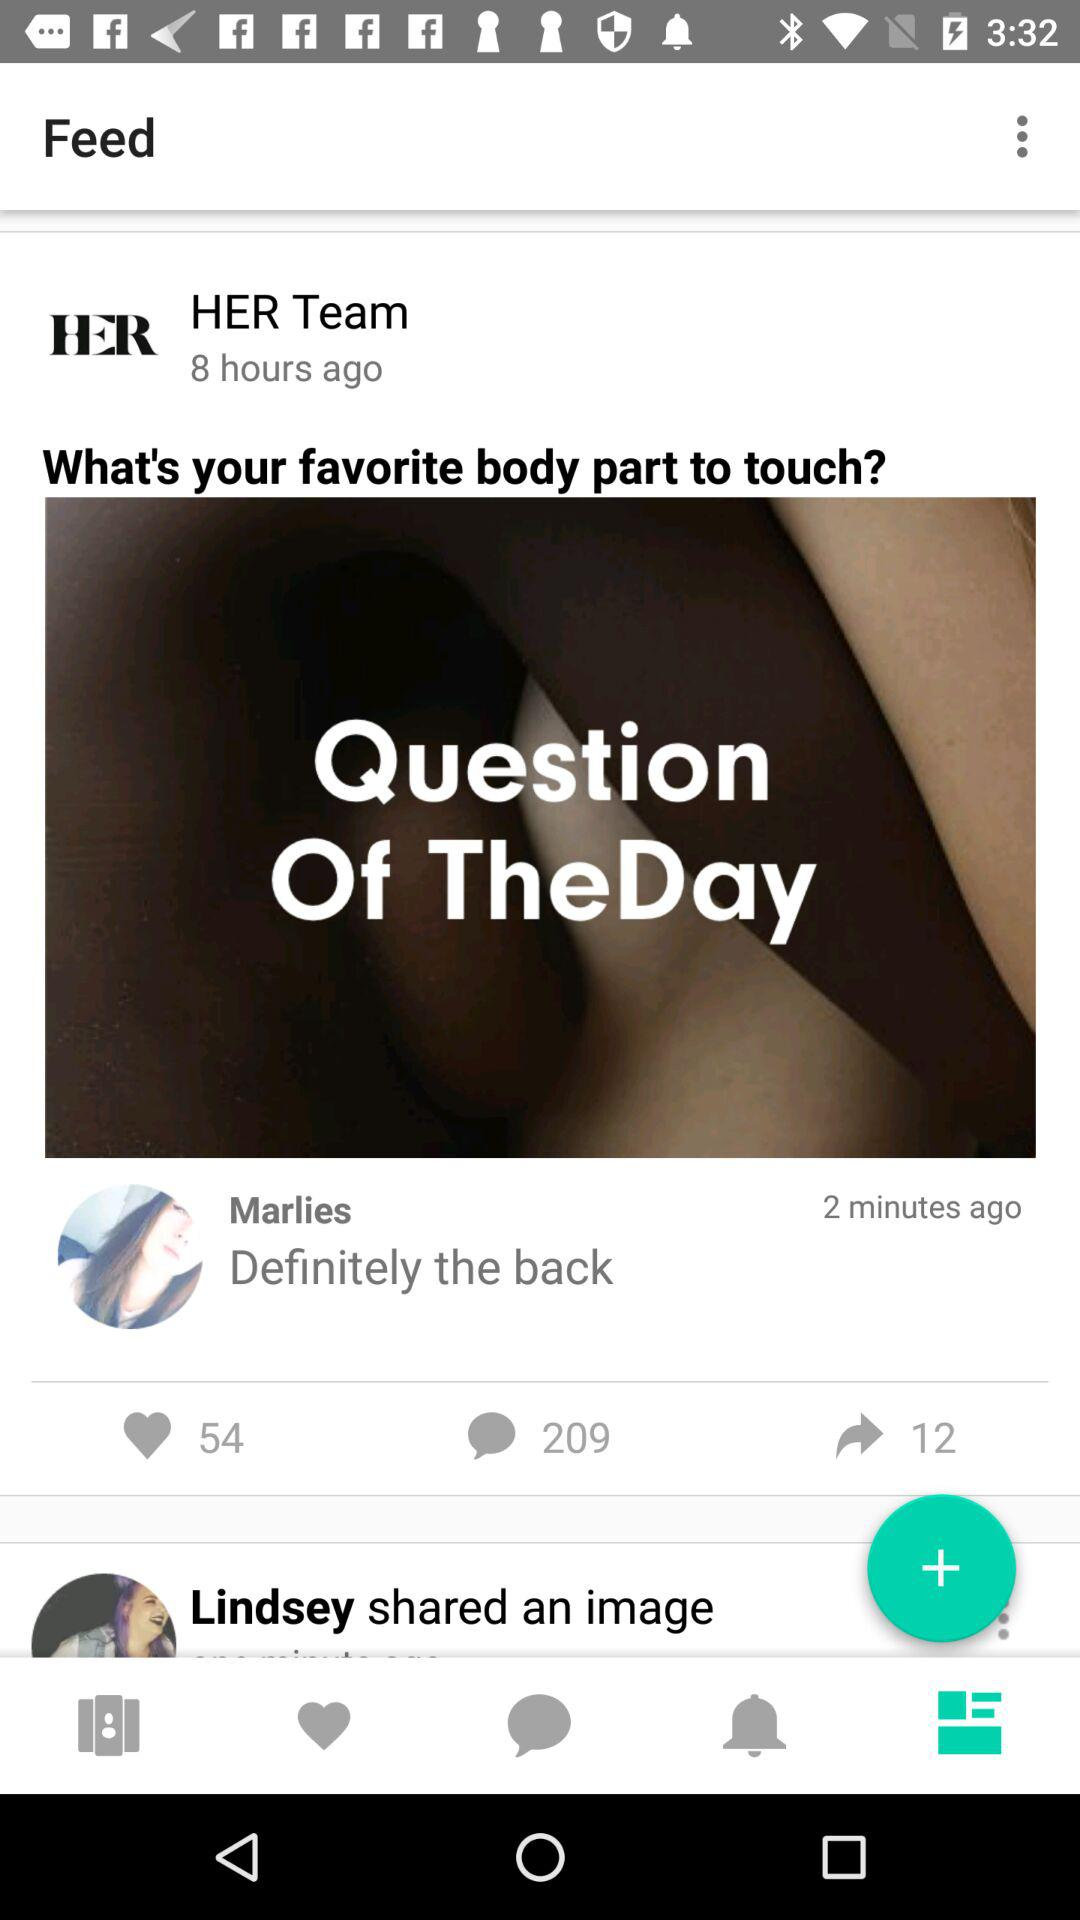What is the count of comments? The count is 209. 